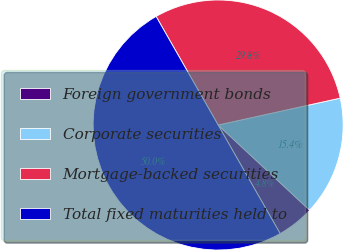Convert chart to OTSL. <chart><loc_0><loc_0><loc_500><loc_500><pie_chart><fcel>Foreign government bonds<fcel>Corporate securities<fcel>Mortgage-backed securities<fcel>Total fixed maturities held to<nl><fcel>4.81%<fcel>15.38%<fcel>29.81%<fcel>50.0%<nl></chart> 